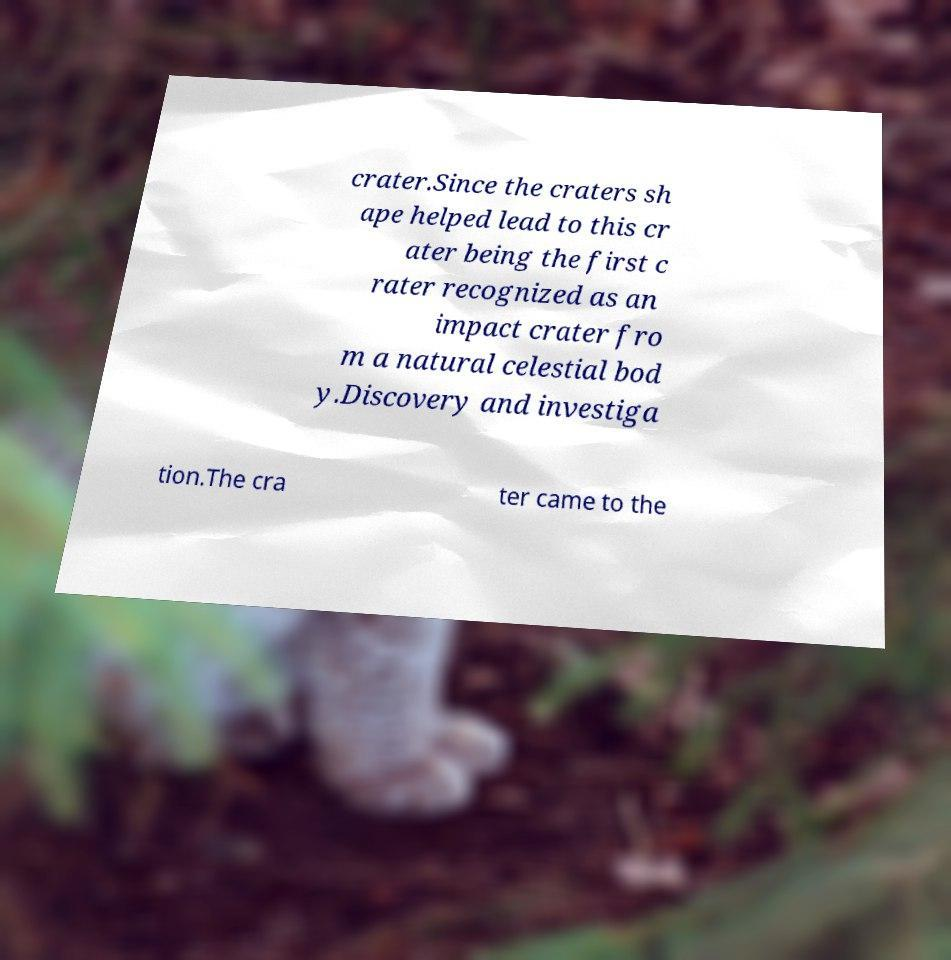Can you read and provide the text displayed in the image?This photo seems to have some interesting text. Can you extract and type it out for me? crater.Since the craters sh ape helped lead to this cr ater being the first c rater recognized as an impact crater fro m a natural celestial bod y.Discovery and investiga tion.The cra ter came to the 